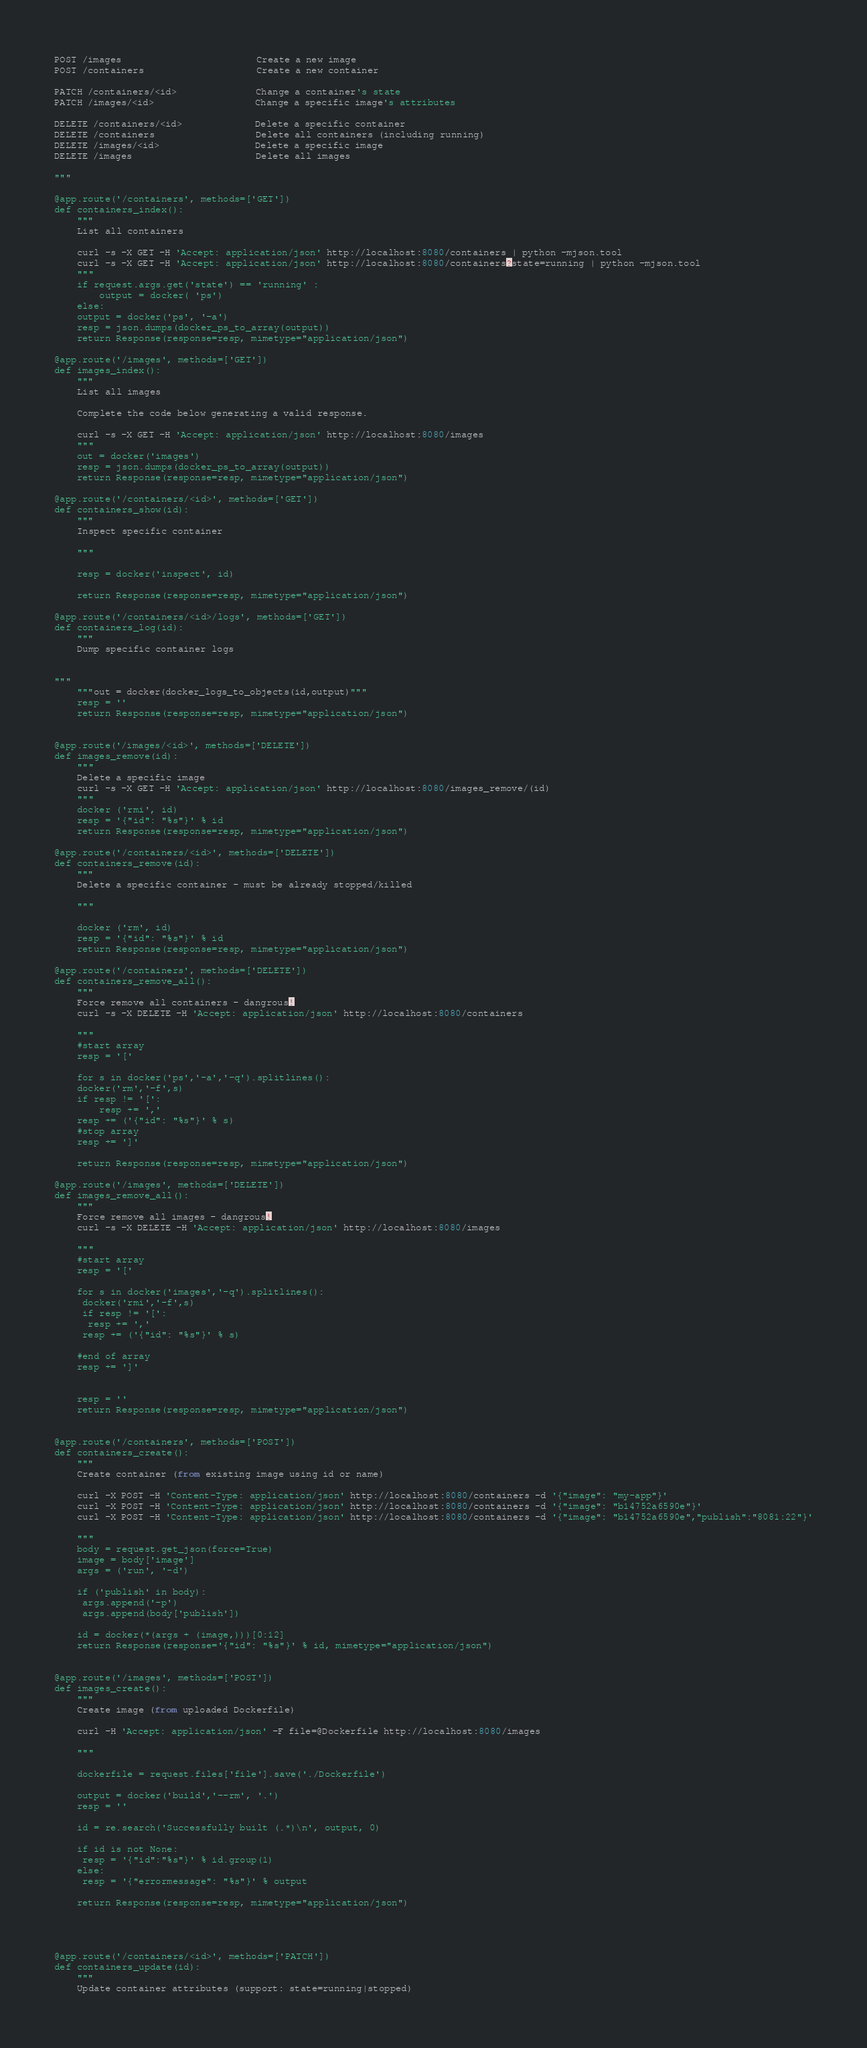<code> <loc_0><loc_0><loc_500><loc_500><_Python_>

POST /images                        Create a new image
POST /containers                    Create a new container

PATCH /containers/<id>              Change a container's state
PATCH /images/<id>                  Change a specific image's attributes

DELETE /containers/<id>             Delete a specific container
DELETE /containers                  Delete all containers (including running)
DELETE /images/<id>                 Delete a specific image
DELETE /images                      Delete all images

"""

@app.route('/containers', methods=['GET'])
def containers_index():
    """
    List all containers
 
    curl -s -X GET -H 'Accept: application/json' http://localhost:8080/containers | python -mjson.tool
    curl -s -X GET -H 'Accept: application/json' http://localhost:8080/containers?state=running | python -mjson.tool
    """
    if request.args.get('state') == 'running' :
    	output = docker( 'ps')
    else:
	output = docker('ps', '-a')
    resp = json.dumps(docker_ps_to_array(output))
    return Response(response=resp, mimetype="application/json")

@app.route('/images', methods=['GET'])
def images_index():
    """
    List all images 
    
    Complete the code below generating a valid response.

    curl -s -X GET -H 'Accept: application/json' http://localhost:8080/images 
    """
    out = docker('images')
    resp = json.dumps(docker_ps_to_array(output))
    return Response(response=resp, mimetype="application/json")

@app.route('/containers/<id>', methods=['GET'])
def containers_show(id):
    """
    Inspect specific container

    """

    resp = docker('inspect', id)

    return Response(response=resp, mimetype="application/json")

@app.route('/containers/<id>/logs', methods=['GET'])
def containers_log(id):
    """
    Dump specific container logs

    
"""
    """out = docker(docker_logs_to_objects(id,output)"""
    resp = ''
    return Response(response=resp, mimetype="application/json")


@app.route('/images/<id>', methods=['DELETE'])
def images_remove(id):
    """
    Delete a specific image
    curl -s -X GET -H 'Accept: application/json' http://localhost:8080/images_remove/(id)
    """
    docker ('rmi', id)
    resp = '{"id": "%s"}' % id
    return Response(response=resp, mimetype="application/json")

@app.route('/containers/<id>', methods=['DELETE'])
def containers_remove(id):
    """
    Delete a specific container - must be already stopped/killed

    """
    
    docker ('rm', id)
    resp = '{"id": "%s"}' % id
    return Response(response=resp, mimetype="application/json")

@app.route('/containers', methods=['DELETE'])
def containers_remove_all():
    """
    Force remove all containers - dangrous!
    curl -s -X DELETE -H 'Accept: application/json' http://localhost:8080/containers

    """
    #start array    
    resp = '['

    for s in docker('ps','-a','-q').splitlines():
	docker('rm','-f',s)
	if resp != '[':
		resp += ','
	resp += ('{"id": "%s"}' % s)
    #stop array
    resp += ']'

    return Response(response=resp, mimetype="application/json")

@app.route('/images', methods=['DELETE'])
def images_remove_all():
    """
    Force remove all images - dangrous!
    curl -s -X DELETE -H 'Accept: application/json' http://localhost:8080/images        

    """
    #start array
    resp = '['

    for s in docker('images','-q').splitlines():
     docker('rmi','-f',s)
     if resp != '[':
      resp += ','
     resp += ('{"id": "%s"}' % s)
	
    #end of array
    resp += ']'  
    

    resp = ''
    return Response(response=resp, mimetype="application/json")


@app.route('/containers', methods=['POST'])
def containers_create():
    """
    Create container (from existing image using id or name)

    curl -X POST -H 'Content-Type: application/json' http://localhost:8080/containers -d '{"image": "my-app"}'
    curl -X POST -H 'Content-Type: application/json' http://localhost:8080/containers -d '{"image": "b14752a6590e"}'
    curl -X POST -H 'Content-Type: application/json' http://localhost:8080/containers -d '{"image": "b14752a6590e","publish":"8081:22"}'

    """
    body = request.get_json(force=True)
    image = body['image']
    args = ('run', '-d')

    if ('publish' in body):
   	 args.append('-p')
   	 args.append(body['publish'])    

    id = docker(*(args + (image,)))[0:12]
    return Response(response='{"id": "%s"}' % id, mimetype="application/json")


@app.route('/images', methods=['POST'])
def images_create():
    """
    Create image (from uploaded Dockerfile)

    curl -H 'Accept: application/json' -F file=@Dockerfile http://localhost:8080/images

    """
    
    dockerfile = request.files['file'].save('./Dockerfile')

    output = docker('build','--rm', '.')
    resp = ''

    id = re.search('Successfully built (.*)\n', output, 0)

    if id is not None:
     resp = '{"id":"%s"}' % id.group(1)
    else:
     resp = '{"errormessage": "%s"}' % output

    return Response(response=resp, mimetype="application/json")




@app.route('/containers/<id>', methods=['PATCH'])
def containers_update(id):
    """
    Update container attributes (support: state=running|stopped)
</code> 